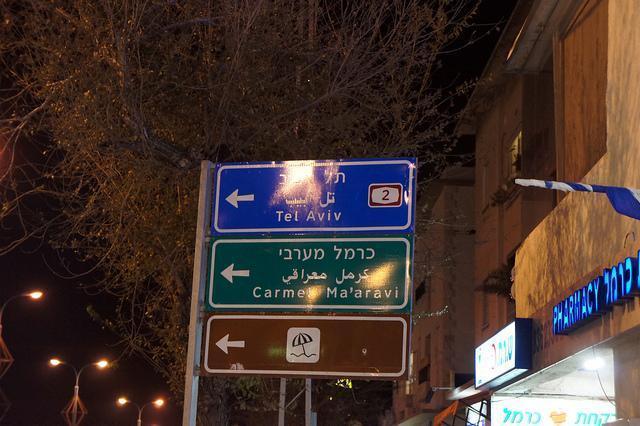How many signs are there?
Give a very brief answer. 3. 